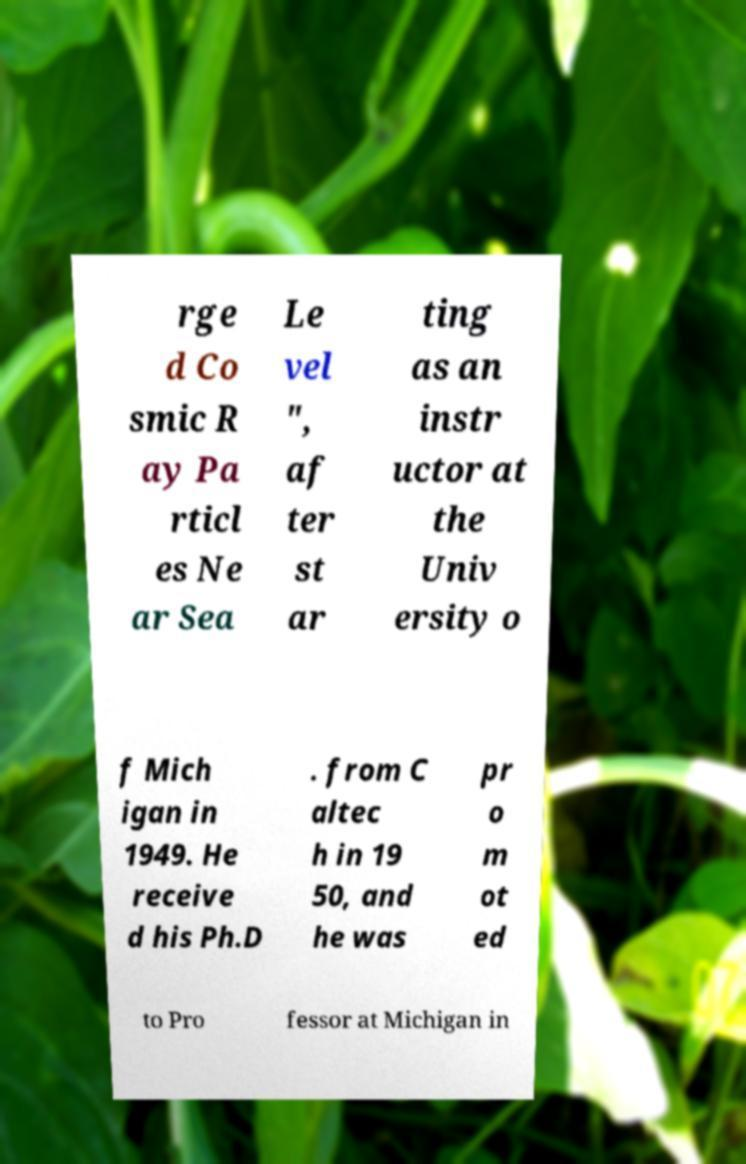There's text embedded in this image that I need extracted. Can you transcribe it verbatim? rge d Co smic R ay Pa rticl es Ne ar Sea Le vel ", af ter st ar ting as an instr uctor at the Univ ersity o f Mich igan in 1949. He receive d his Ph.D . from C altec h in 19 50, and he was pr o m ot ed to Pro fessor at Michigan in 